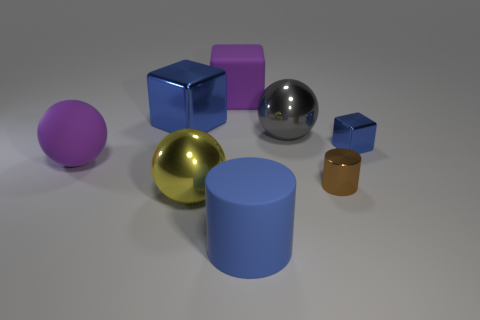Are there any tiny blue cubes?
Your response must be concise. Yes. There is a big purple thing in front of the big gray metallic thing; what is its material?
Provide a succinct answer. Rubber. There is a tiny object that is the same color as the large shiny cube; what material is it?
Provide a short and direct response. Metal. How many big objects are blue metallic cubes or yellow shiny objects?
Make the answer very short. 2. What is the color of the big shiny block?
Your answer should be compact. Blue. There is a big metallic thing behind the big gray ball; are there any matte objects that are behind it?
Ensure brevity in your answer.  Yes. Are there fewer large purple cubes that are in front of the big blue matte thing than large blue spheres?
Keep it short and to the point. No. Is the large block behind the big blue shiny cube made of the same material as the small brown cylinder?
Give a very brief answer. No. What color is the small thing that is the same material as the small cylinder?
Provide a succinct answer. Blue. Are there fewer matte balls that are right of the brown thing than yellow metallic balls on the right side of the big yellow shiny thing?
Offer a terse response. No. 